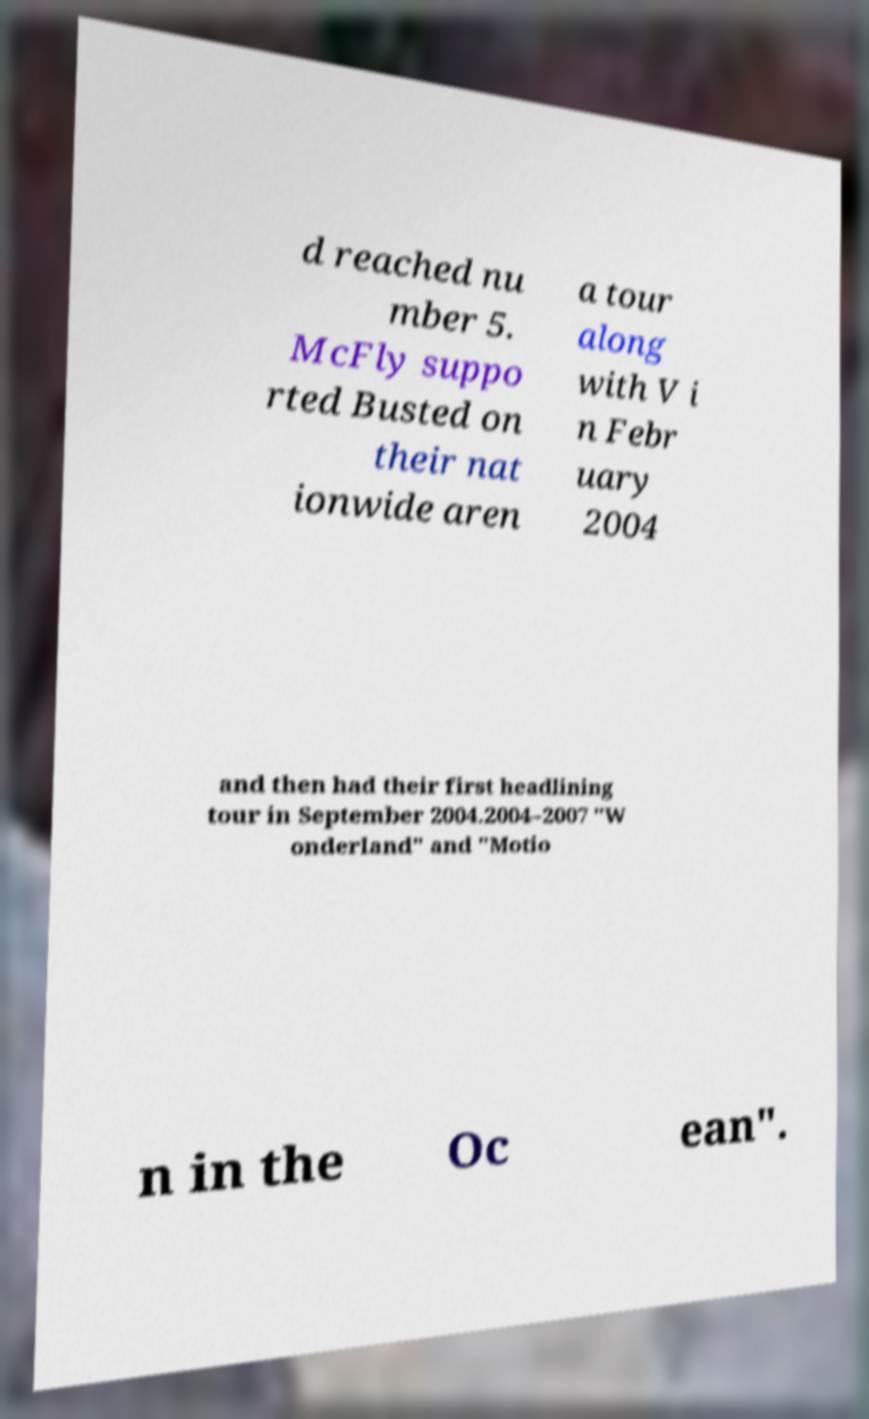Can you read and provide the text displayed in the image?This photo seems to have some interesting text. Can you extract and type it out for me? d reached nu mber 5. McFly suppo rted Busted on their nat ionwide aren a tour along with V i n Febr uary 2004 and then had their first headlining tour in September 2004.2004–2007 "W onderland" and "Motio n in the Oc ean". 